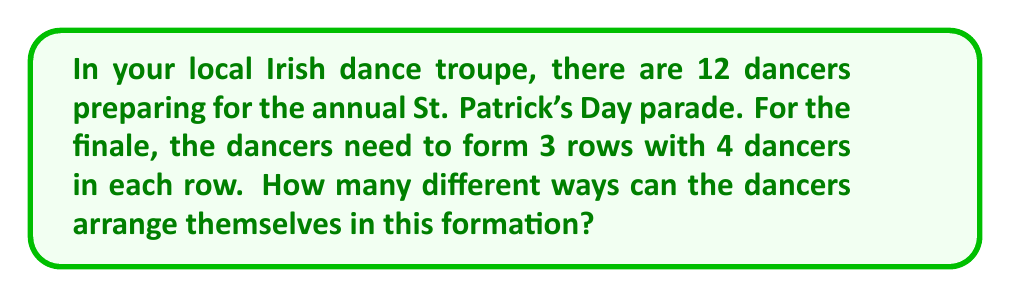Help me with this question. Let's approach this step-by-step:

1) First, we need to understand that this is a permutation problem. We are arranging 12 distinct dancers into specific positions.

2) We can think of this as filling 12 distinct positions (3 rows of 4) with 12 distinct dancers.

3) For the first position, we have 12 choices of dancers.

4) For the second position, we have 11 remaining choices.

5) For the third position, we have 10 remaining choices.

6) This pattern continues until we place the last dancer.

7) Therefore, the total number of arrangements is:

   $$12 \times 11 \times 10 \times 9 \times 8 \times 7 \times 6 \times 5 \times 4 \times 3 \times 2 \times 1$$

8) This is equivalent to 12 factorial, denoted as 12!

9) We can calculate this:

   $$12! = 479,001,600$$

Therefore, there are 479,001,600 different ways the dancers can arrange themselves in the formation.
Answer: 479,001,600 